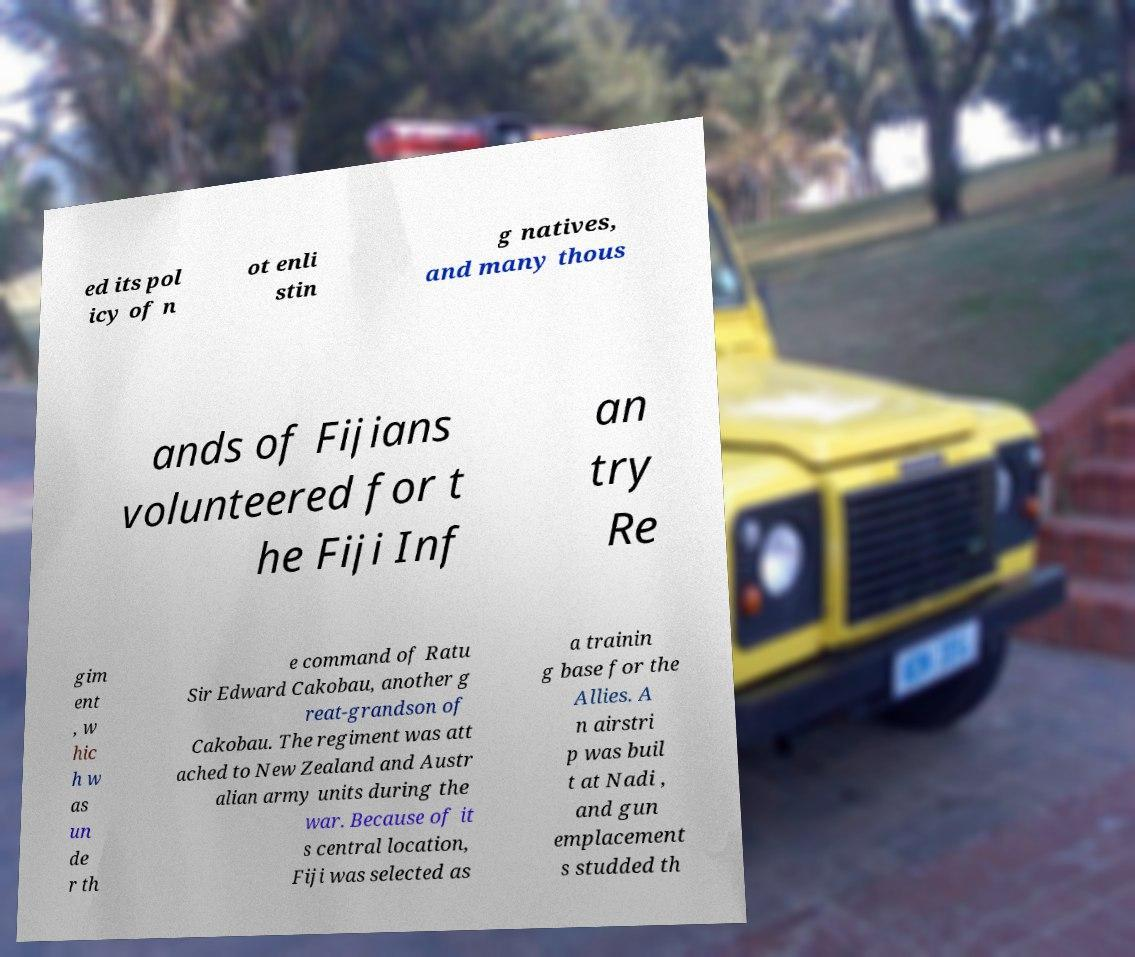Could you assist in decoding the text presented in this image and type it out clearly? ed its pol icy of n ot enli stin g natives, and many thous ands of Fijians volunteered for t he Fiji Inf an try Re gim ent , w hic h w as un de r th e command of Ratu Sir Edward Cakobau, another g reat-grandson of Cakobau. The regiment was att ached to New Zealand and Austr alian army units during the war. Because of it s central location, Fiji was selected as a trainin g base for the Allies. A n airstri p was buil t at Nadi , and gun emplacement s studded th 